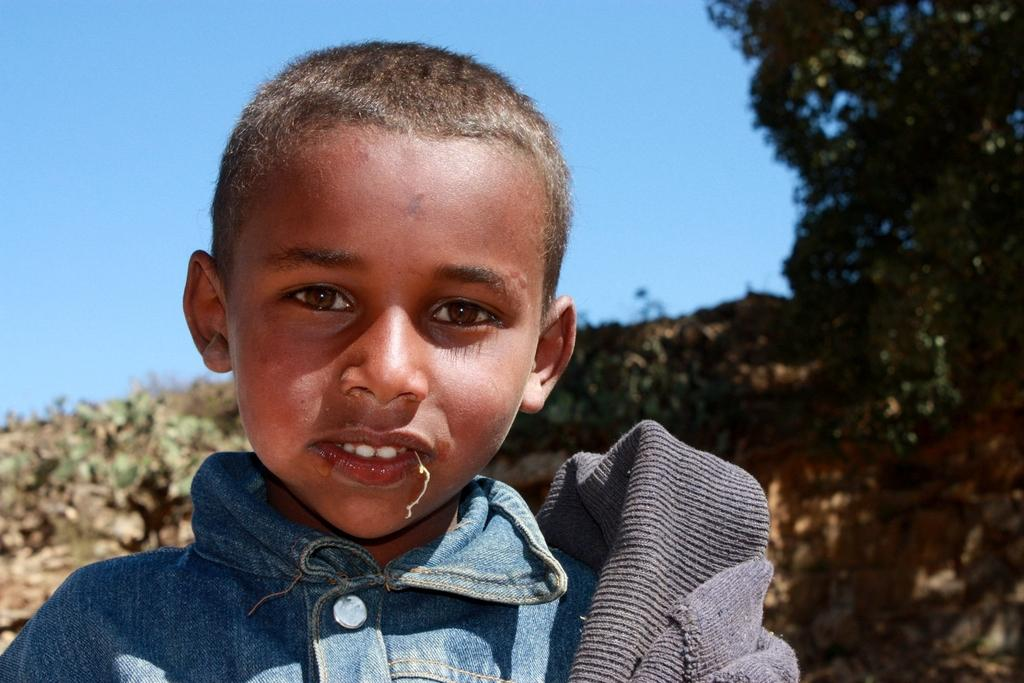What is the main subject of the image? The main subject of the image is a kid. What can be seen in the background of the image? Trees and the sky are visible in the background of the image. What type of window can be seen in the image? There is no window present in the image. What process is being depicted in the image? The image does not depict any specific process; it simply shows a kid and the background. 